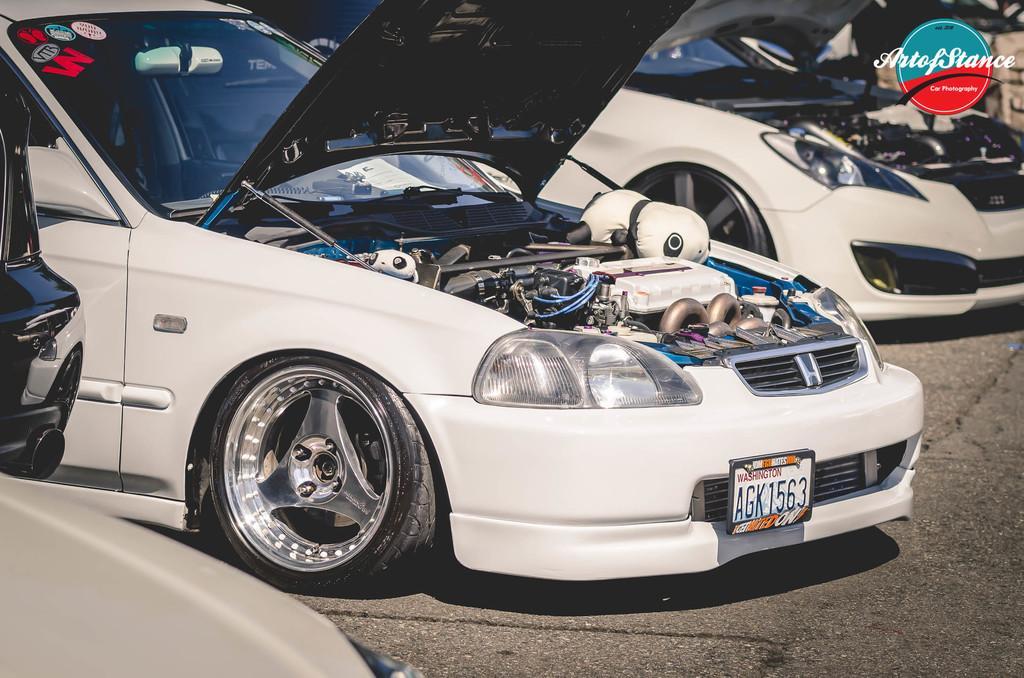Could you give a brief overview of what you see in this image? In this image there are some vehicles which are opened and also we could see some engines, at the bottom there is a road. 